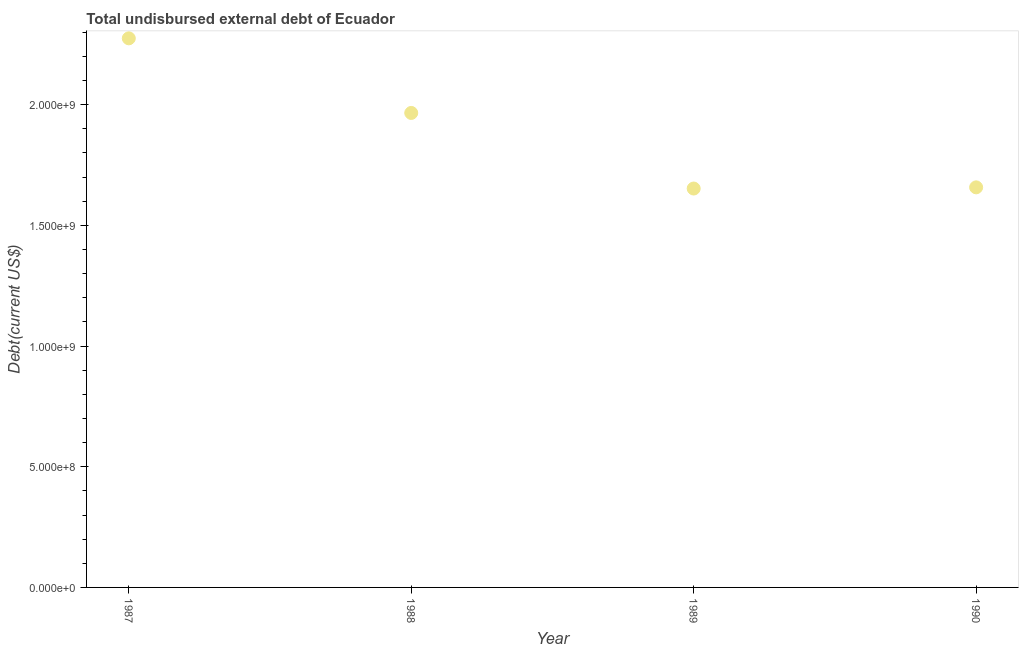What is the total debt in 1987?
Your answer should be compact. 2.27e+09. Across all years, what is the maximum total debt?
Offer a terse response. 2.27e+09. Across all years, what is the minimum total debt?
Your answer should be compact. 1.65e+09. In which year was the total debt minimum?
Make the answer very short. 1989. What is the sum of the total debt?
Offer a terse response. 7.55e+09. What is the difference between the total debt in 1987 and 1989?
Your response must be concise. 6.22e+08. What is the average total debt per year?
Make the answer very short. 1.89e+09. What is the median total debt?
Offer a terse response. 1.81e+09. In how many years, is the total debt greater than 1100000000 US$?
Your response must be concise. 4. Do a majority of the years between 1990 and 1989 (inclusive) have total debt greater than 1400000000 US$?
Ensure brevity in your answer.  No. What is the ratio of the total debt in 1987 to that in 1989?
Offer a terse response. 1.38. Is the total debt in 1987 less than that in 1988?
Ensure brevity in your answer.  No. What is the difference between the highest and the second highest total debt?
Your answer should be very brief. 3.09e+08. What is the difference between the highest and the lowest total debt?
Your answer should be compact. 6.22e+08. How many dotlines are there?
Provide a short and direct response. 1. What is the difference between two consecutive major ticks on the Y-axis?
Keep it short and to the point. 5.00e+08. Are the values on the major ticks of Y-axis written in scientific E-notation?
Provide a short and direct response. Yes. What is the title of the graph?
Provide a succinct answer. Total undisbursed external debt of Ecuador. What is the label or title of the Y-axis?
Your answer should be compact. Debt(current US$). What is the Debt(current US$) in 1987?
Keep it short and to the point. 2.27e+09. What is the Debt(current US$) in 1988?
Your answer should be compact. 1.97e+09. What is the Debt(current US$) in 1989?
Your answer should be very brief. 1.65e+09. What is the Debt(current US$) in 1990?
Offer a very short reply. 1.66e+09. What is the difference between the Debt(current US$) in 1987 and 1988?
Keep it short and to the point. 3.09e+08. What is the difference between the Debt(current US$) in 1987 and 1989?
Offer a terse response. 6.22e+08. What is the difference between the Debt(current US$) in 1987 and 1990?
Offer a terse response. 6.17e+08. What is the difference between the Debt(current US$) in 1988 and 1989?
Provide a short and direct response. 3.13e+08. What is the difference between the Debt(current US$) in 1988 and 1990?
Offer a terse response. 3.08e+08. What is the difference between the Debt(current US$) in 1989 and 1990?
Your answer should be very brief. -4.90e+06. What is the ratio of the Debt(current US$) in 1987 to that in 1988?
Keep it short and to the point. 1.16. What is the ratio of the Debt(current US$) in 1987 to that in 1989?
Give a very brief answer. 1.38. What is the ratio of the Debt(current US$) in 1987 to that in 1990?
Give a very brief answer. 1.37. What is the ratio of the Debt(current US$) in 1988 to that in 1989?
Offer a terse response. 1.19. What is the ratio of the Debt(current US$) in 1988 to that in 1990?
Provide a short and direct response. 1.19. What is the ratio of the Debt(current US$) in 1989 to that in 1990?
Offer a terse response. 1. 